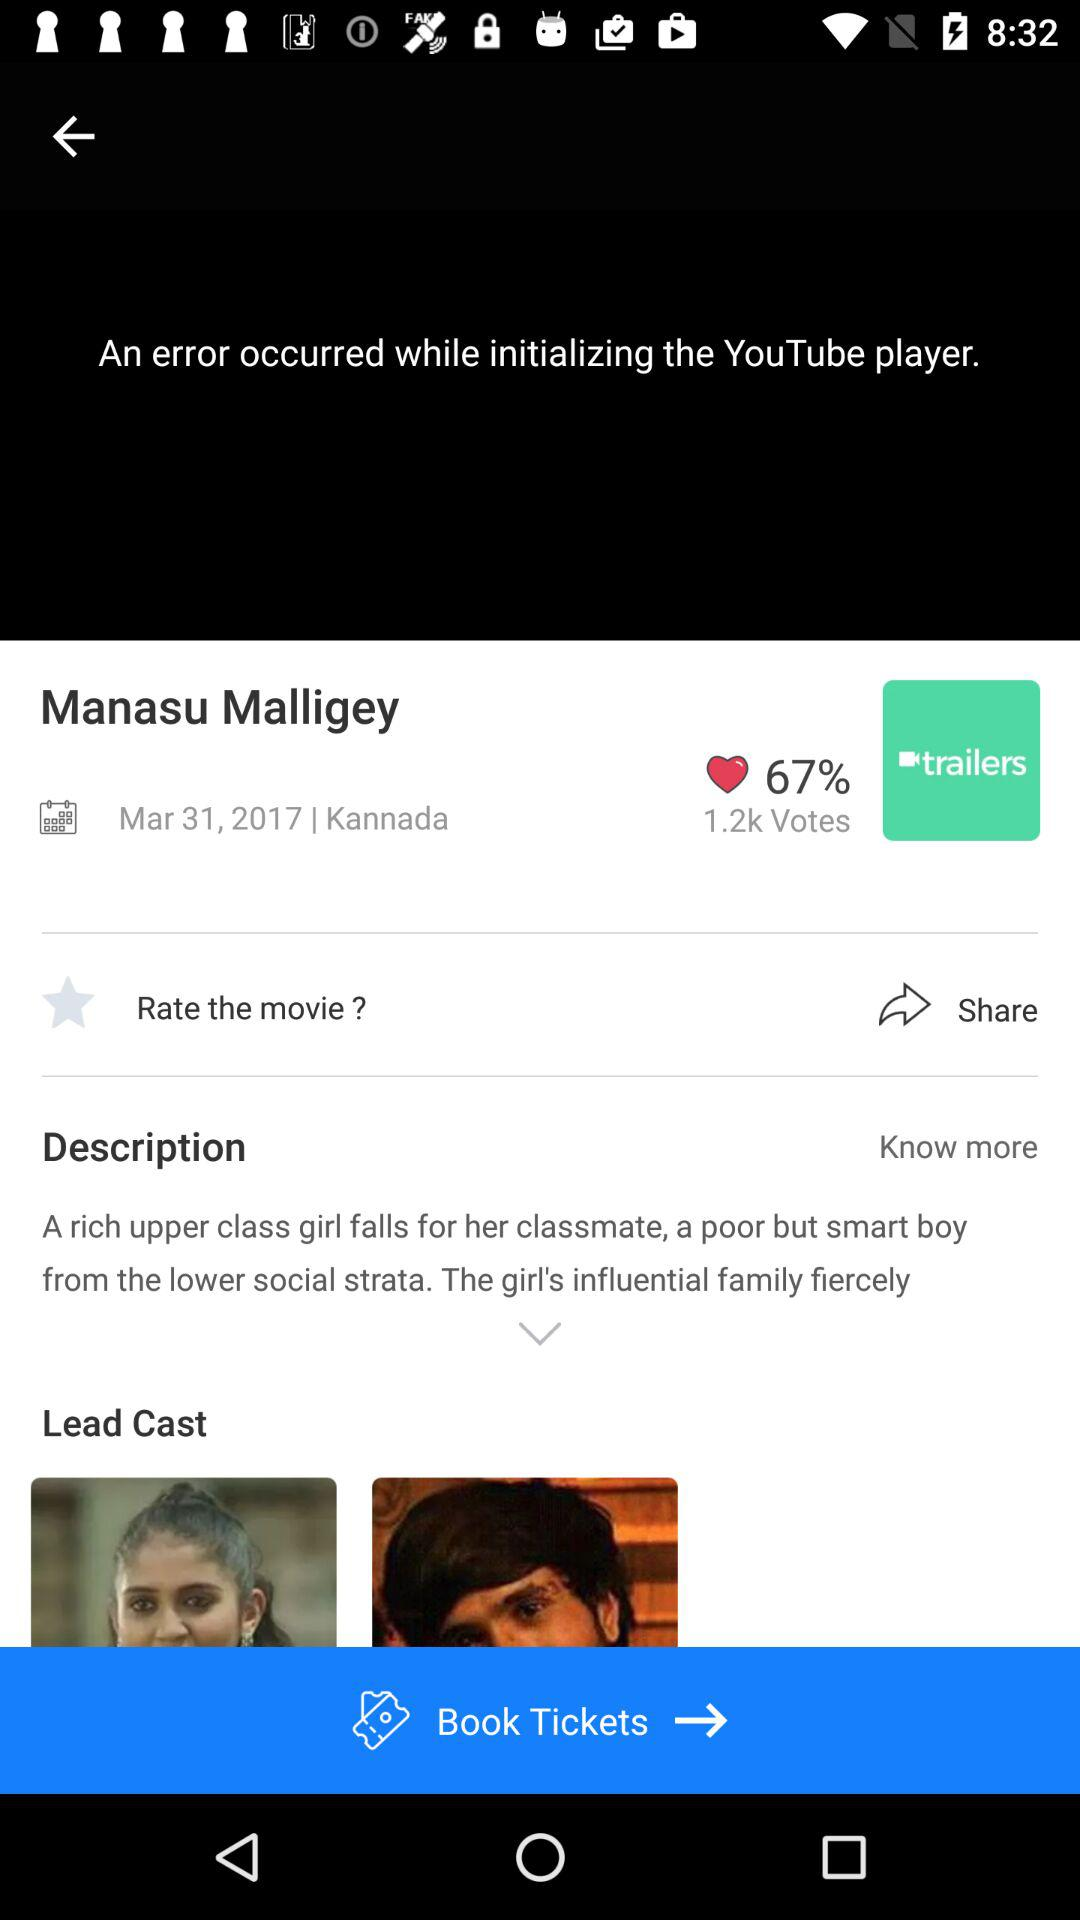In what language is the movie available? The movie is available in Kannada. 